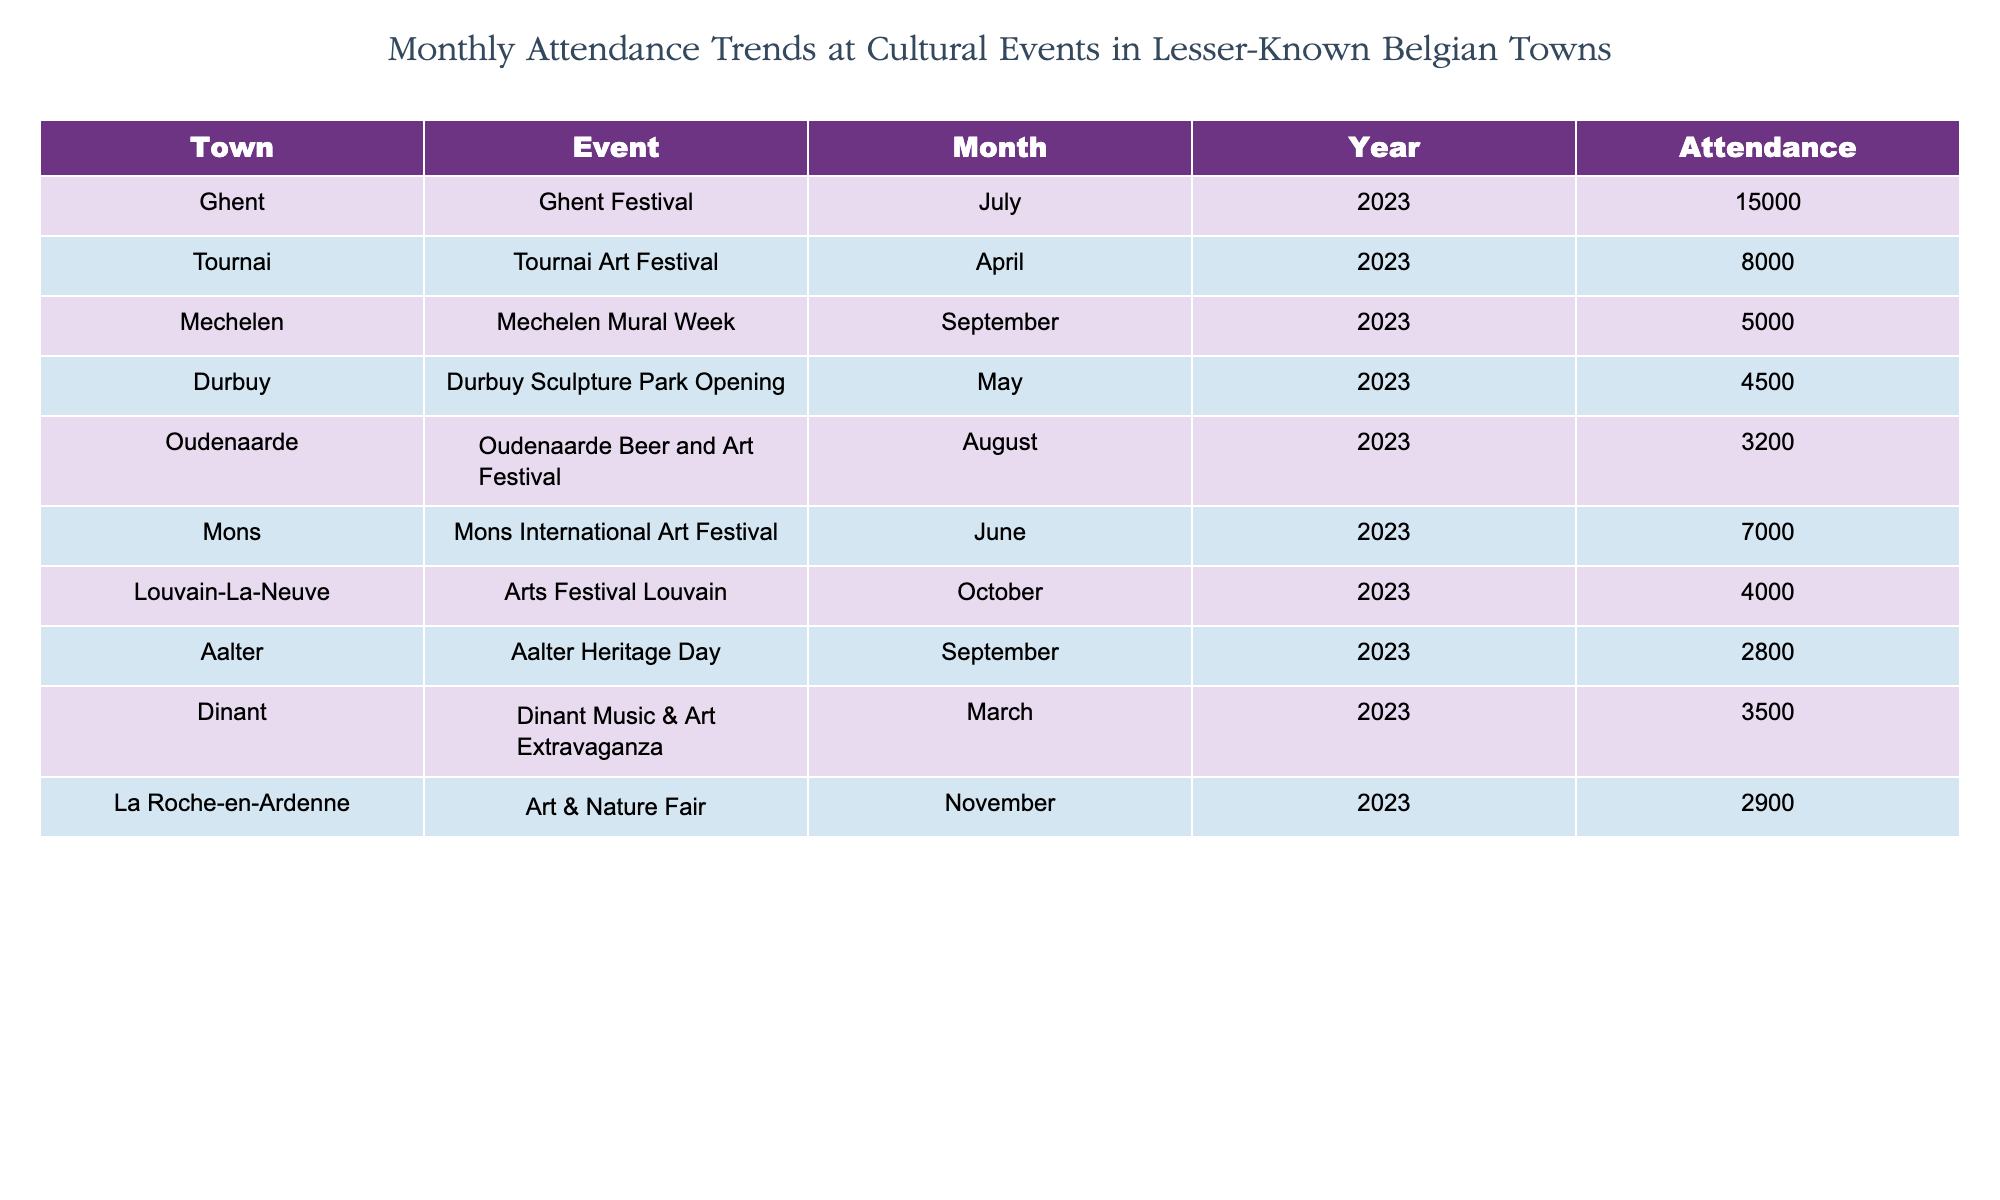What town hosted the event with the highest attendance in July 2023? The table lists the Ghent Festival in Ghent with an attendance of 15000 in July 2023, which is higher than any other event listed for that month.
Answer: Ghent What is the attendance for the Tournai Art Festival in April 2023? The Tournai Art Festival, as shown in the table, had an attendance of 8000 in April 2023.
Answer: 8000 How many people attended the Durbuy Sculpture Park Opening compared to the Oudenaarde Beer and Art Festival? The attendance for the Durbuy Sculpture Park Opening was 4500 while the Oudenaarde Beer and Art Festival had 3200 attendees. The difference can be calculated as 4500 - 3200 = 1300.
Answer: 1300 more What is the total attendance for cultural events in September 2023? The events in September 2023 include Mechelen Mural Week with 5000 attendees and Aalter Heritage Day with 2800 attendees. The total is calculated by adding both attendance figures: 5000 + 2800 = 7800.
Answer: 7800 Did any cultural event in October 2023 have more than 4000 attendees? The table shows that the Arts Festival Louvain in October 2023 had exactly 4000 attendees, thus it did not exceed that number.
Answer: No 